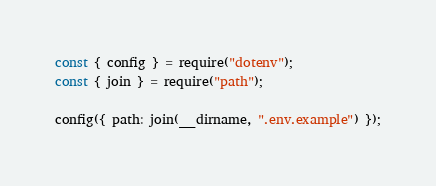<code> <loc_0><loc_0><loc_500><loc_500><_JavaScript_>const { config } = require("dotenv");
const { join } = require("path");

config({ path: join(__dirname, ".env.example") });
</code> 